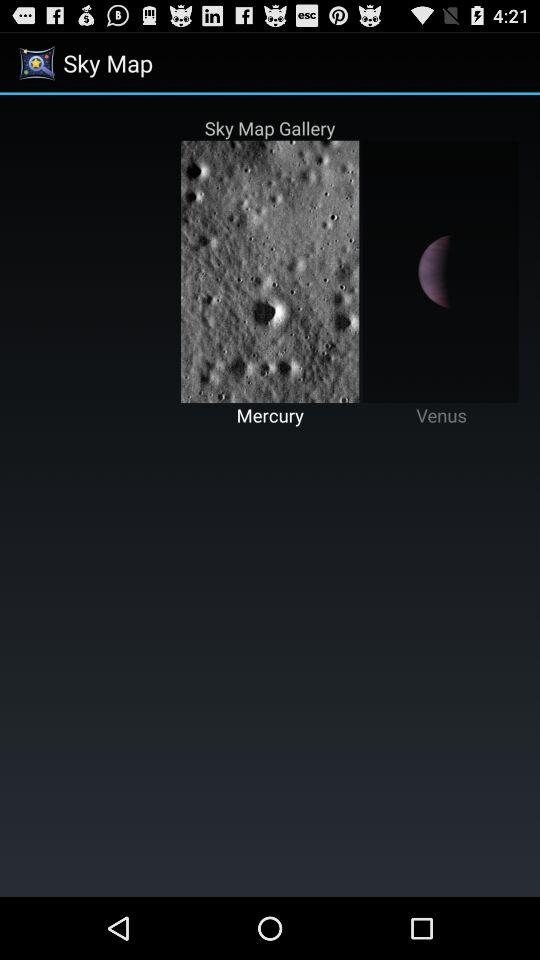What two planets are being shown? The two planets that are being shown are "Mercury" and "Venus". 